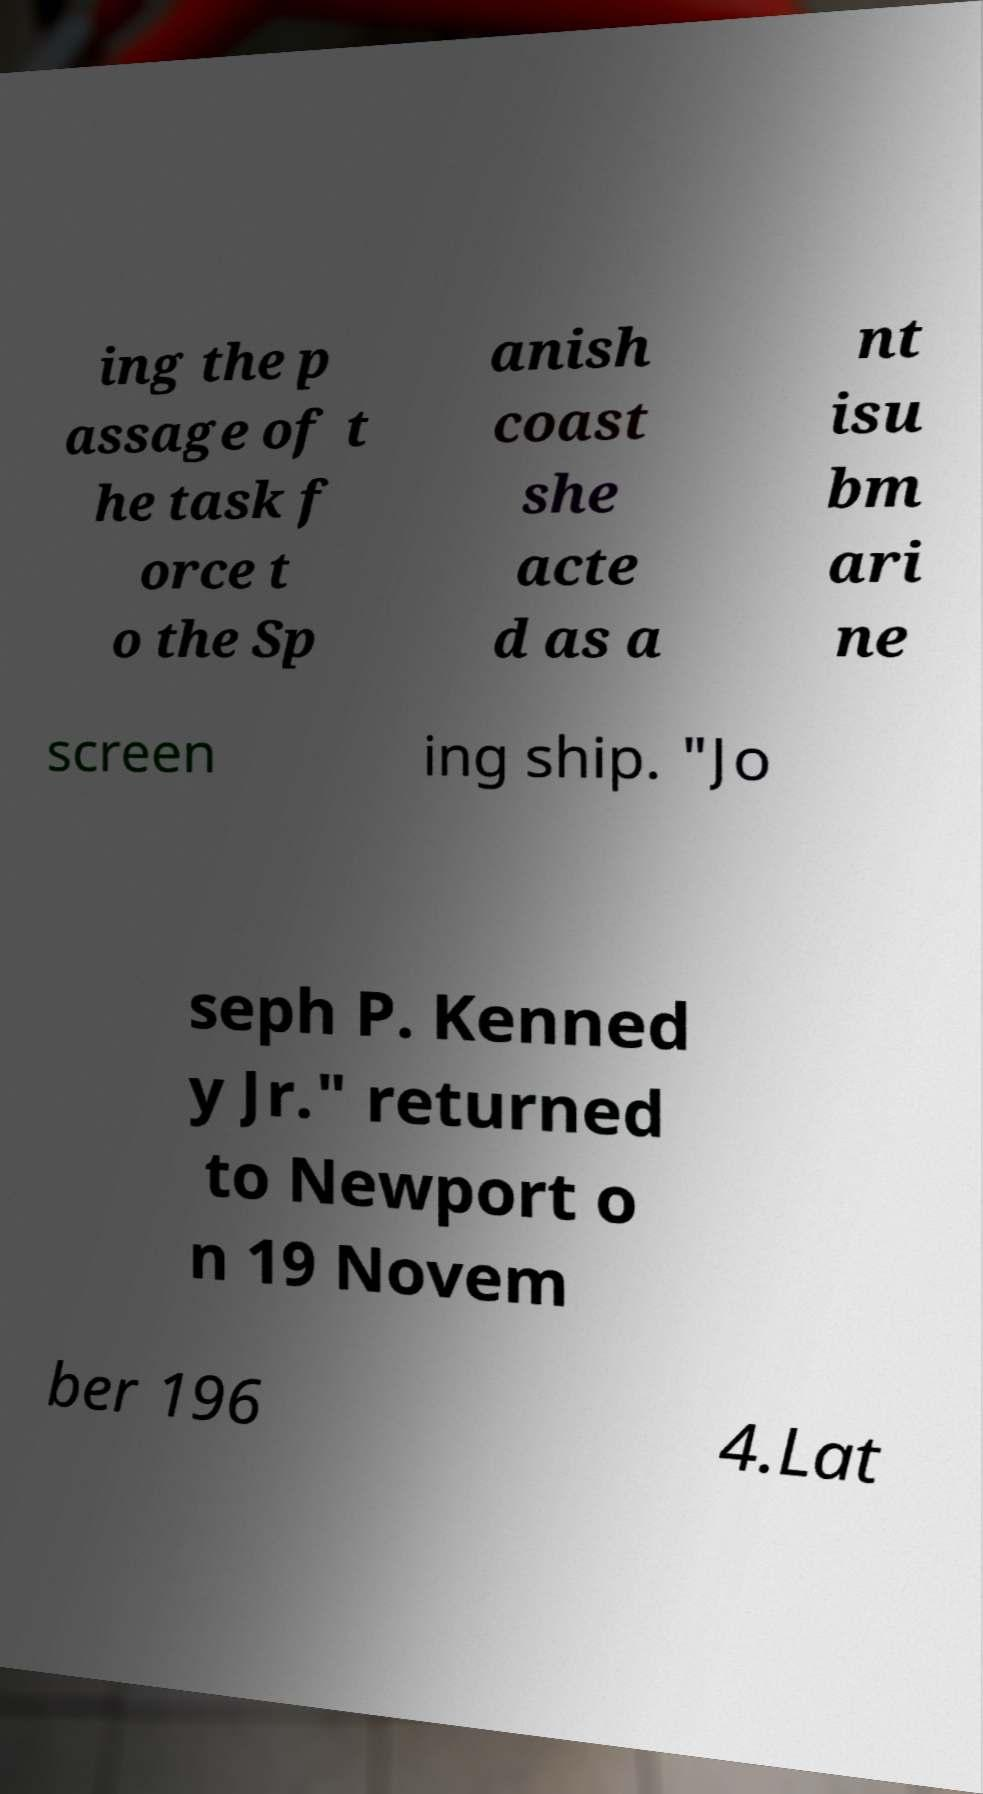Please identify and transcribe the text found in this image. ing the p assage of t he task f orce t o the Sp anish coast she acte d as a nt isu bm ari ne screen ing ship. "Jo seph P. Kenned y Jr." returned to Newport o n 19 Novem ber 196 4.Lat 